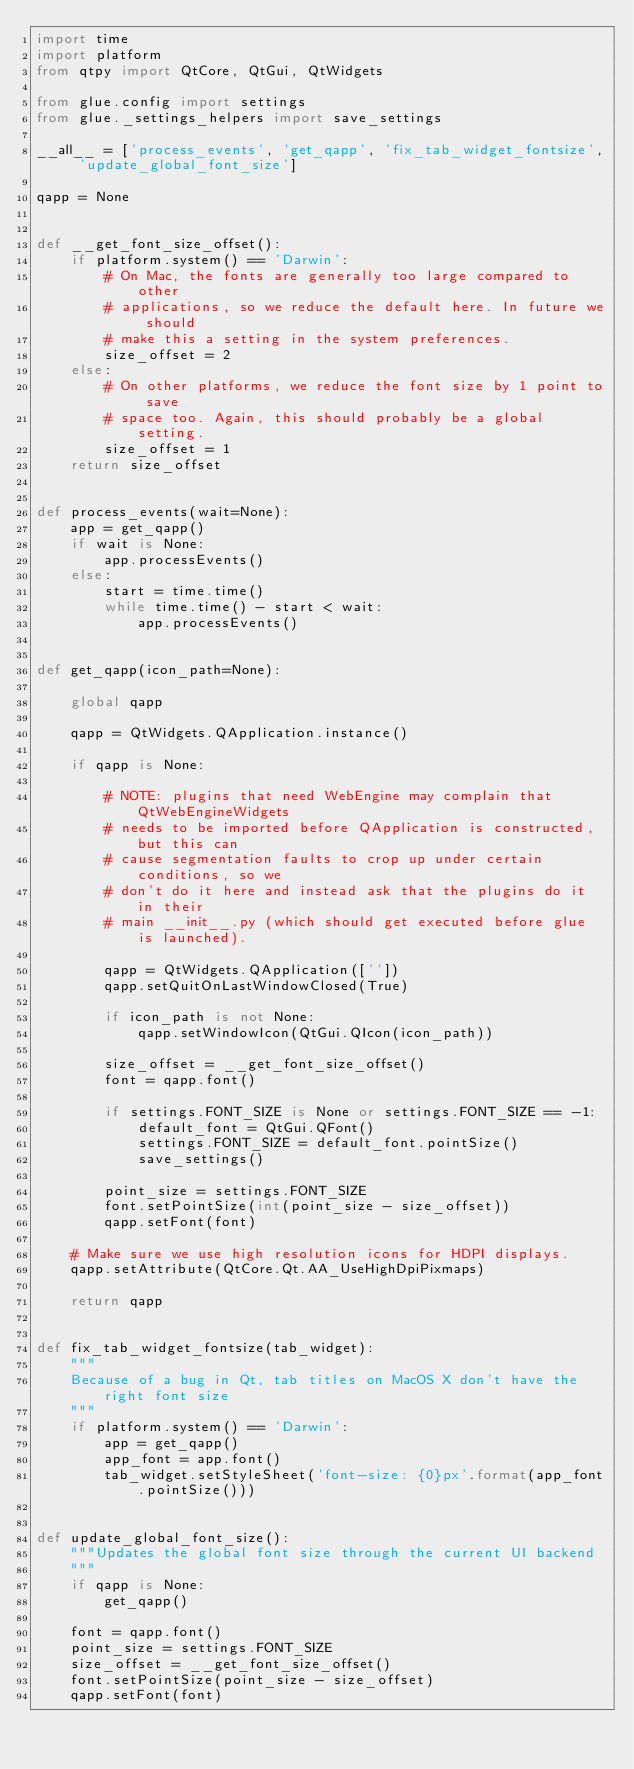Convert code to text. <code><loc_0><loc_0><loc_500><loc_500><_Python_>import time
import platform
from qtpy import QtCore, QtGui, QtWidgets

from glue.config import settings
from glue._settings_helpers import save_settings

__all__ = ['process_events', 'get_qapp', 'fix_tab_widget_fontsize', 'update_global_font_size']

qapp = None


def __get_font_size_offset():
    if platform.system() == 'Darwin':
        # On Mac, the fonts are generally too large compared to other
        # applications, so we reduce the default here. In future we should
        # make this a setting in the system preferences.
        size_offset = 2
    else:
        # On other platforms, we reduce the font size by 1 point to save
        # space too. Again, this should probably be a global setting.
        size_offset = 1
    return size_offset


def process_events(wait=None):
    app = get_qapp()
    if wait is None:
        app.processEvents()
    else:
        start = time.time()
        while time.time() - start < wait:
            app.processEvents()


def get_qapp(icon_path=None):

    global qapp

    qapp = QtWidgets.QApplication.instance()

    if qapp is None:

        # NOTE: plugins that need WebEngine may complain that QtWebEngineWidgets
        # needs to be imported before QApplication is constructed, but this can
        # cause segmentation faults to crop up under certain conditions, so we
        # don't do it here and instead ask that the plugins do it in their
        # main __init__.py (which should get executed before glue is launched).

        qapp = QtWidgets.QApplication([''])
        qapp.setQuitOnLastWindowClosed(True)

        if icon_path is not None:
            qapp.setWindowIcon(QtGui.QIcon(icon_path))

        size_offset = __get_font_size_offset()
        font = qapp.font()

        if settings.FONT_SIZE is None or settings.FONT_SIZE == -1:
            default_font = QtGui.QFont()
            settings.FONT_SIZE = default_font.pointSize()
            save_settings()

        point_size = settings.FONT_SIZE
        font.setPointSize(int(point_size - size_offset))
        qapp.setFont(font)

    # Make sure we use high resolution icons for HDPI displays.
    qapp.setAttribute(QtCore.Qt.AA_UseHighDpiPixmaps)

    return qapp


def fix_tab_widget_fontsize(tab_widget):
    """
    Because of a bug in Qt, tab titles on MacOS X don't have the right font size
    """
    if platform.system() == 'Darwin':
        app = get_qapp()
        app_font = app.font()
        tab_widget.setStyleSheet('font-size: {0}px'.format(app_font.pointSize()))


def update_global_font_size():
    """Updates the global font size through the current UI backend
    """
    if qapp is None:
        get_qapp()

    font = qapp.font()
    point_size = settings.FONT_SIZE
    size_offset = __get_font_size_offset()
    font.setPointSize(point_size - size_offset)
    qapp.setFont(font)
</code> 